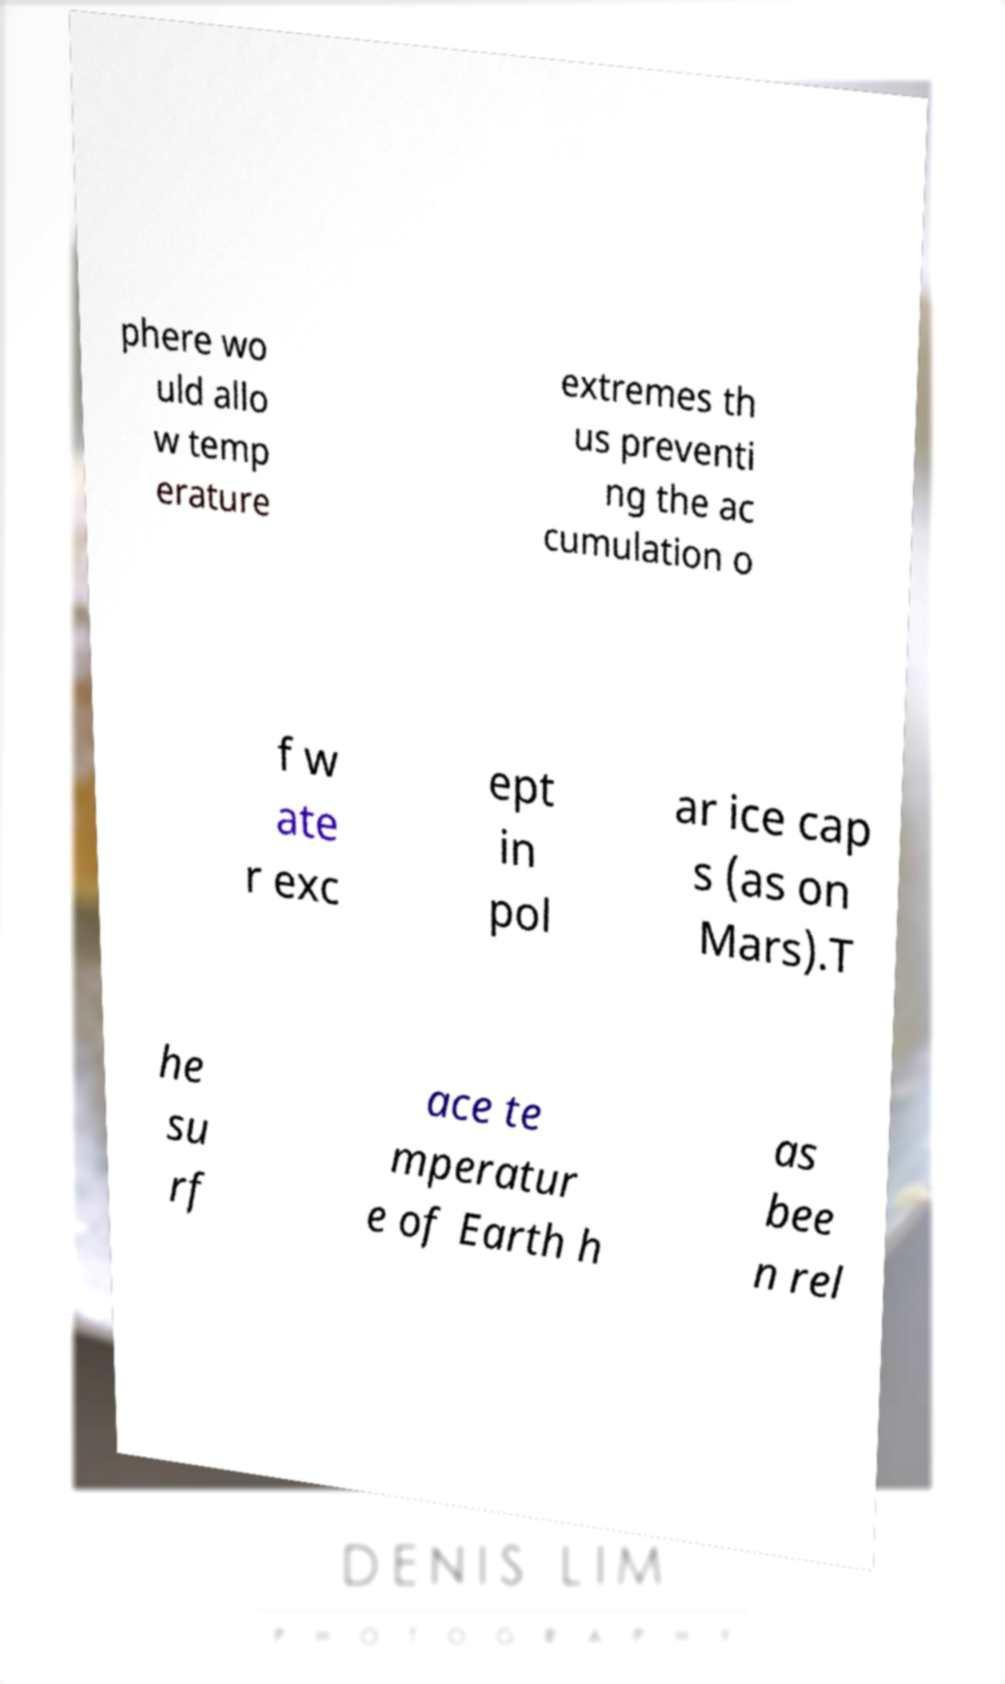For documentation purposes, I need the text within this image transcribed. Could you provide that? phere wo uld allo w temp erature extremes th us preventi ng the ac cumulation o f w ate r exc ept in pol ar ice cap s (as on Mars).T he su rf ace te mperatur e of Earth h as bee n rel 